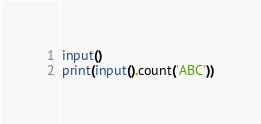<code> <loc_0><loc_0><loc_500><loc_500><_Python_>input()
print(input().count('ABC'))
</code> 